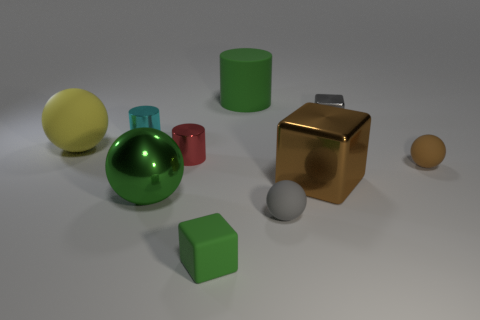What could these objects be used for in a real-world setting? The objects in the image, while simple in shape, can be used for various purposes. The spheres might serve as decorative items or as part of a game, the cubes could be children's building blocks, and the metallic-looking brown block looks like it could be a paperweight or an ornamental object. Which of these objects seems out of place in this collection and why? The metallic brown block stands out among the collection because of its shiny, reflective surface which contrasts with the matte finishes of the other items. Its material gives it a more luxurious and robust look, possibly indicating a different function or higher value. 